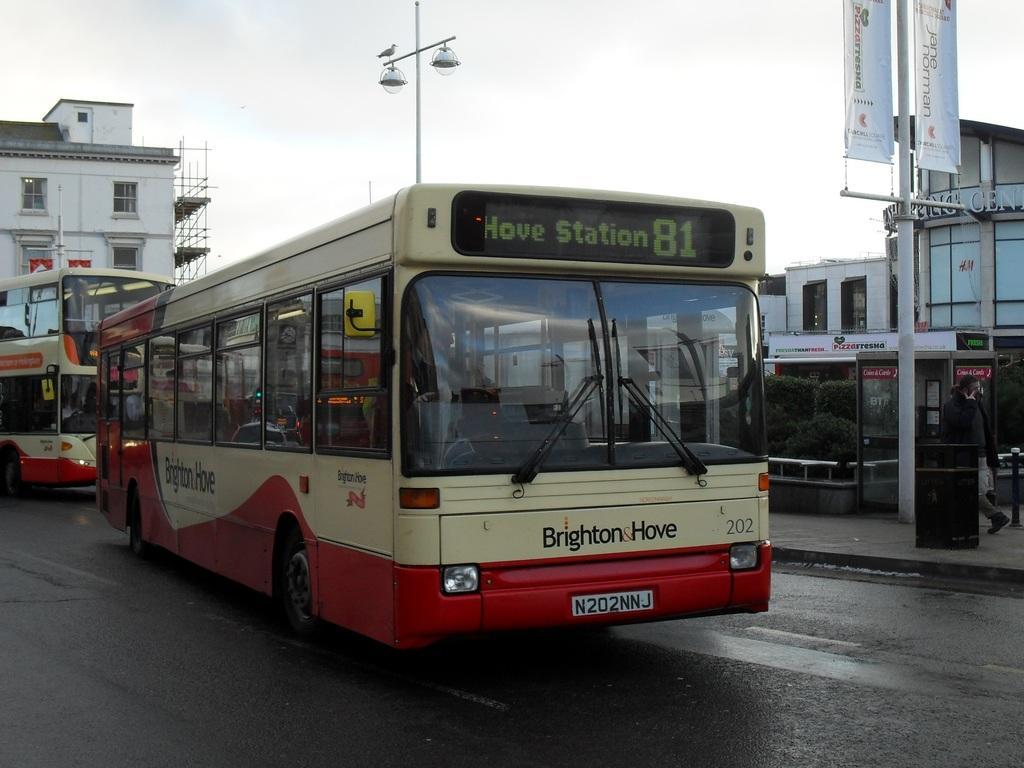How would you summarize this image in a sentence or two? In this picture we can see buses on the road. 